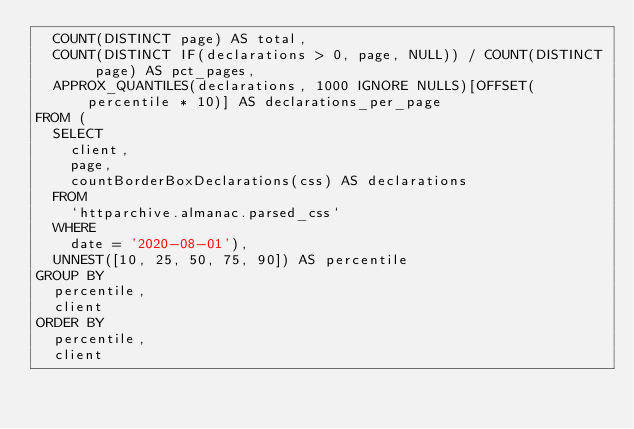Convert code to text. <code><loc_0><loc_0><loc_500><loc_500><_SQL_>  COUNT(DISTINCT page) AS total,
  COUNT(DISTINCT IF(declarations > 0, page, NULL)) / COUNT(DISTINCT page) AS pct_pages,
  APPROX_QUANTILES(declarations, 1000 IGNORE NULLS)[OFFSET(percentile * 10)] AS declarations_per_page
FROM (
  SELECT
    client,
    page,
    countBorderBoxDeclarations(css) AS declarations
  FROM
    `httparchive.almanac.parsed_css`
  WHERE
    date = '2020-08-01'),
  UNNEST([10, 25, 50, 75, 90]) AS percentile
GROUP BY
  percentile,
  client
ORDER BY
  percentile,
  client</code> 